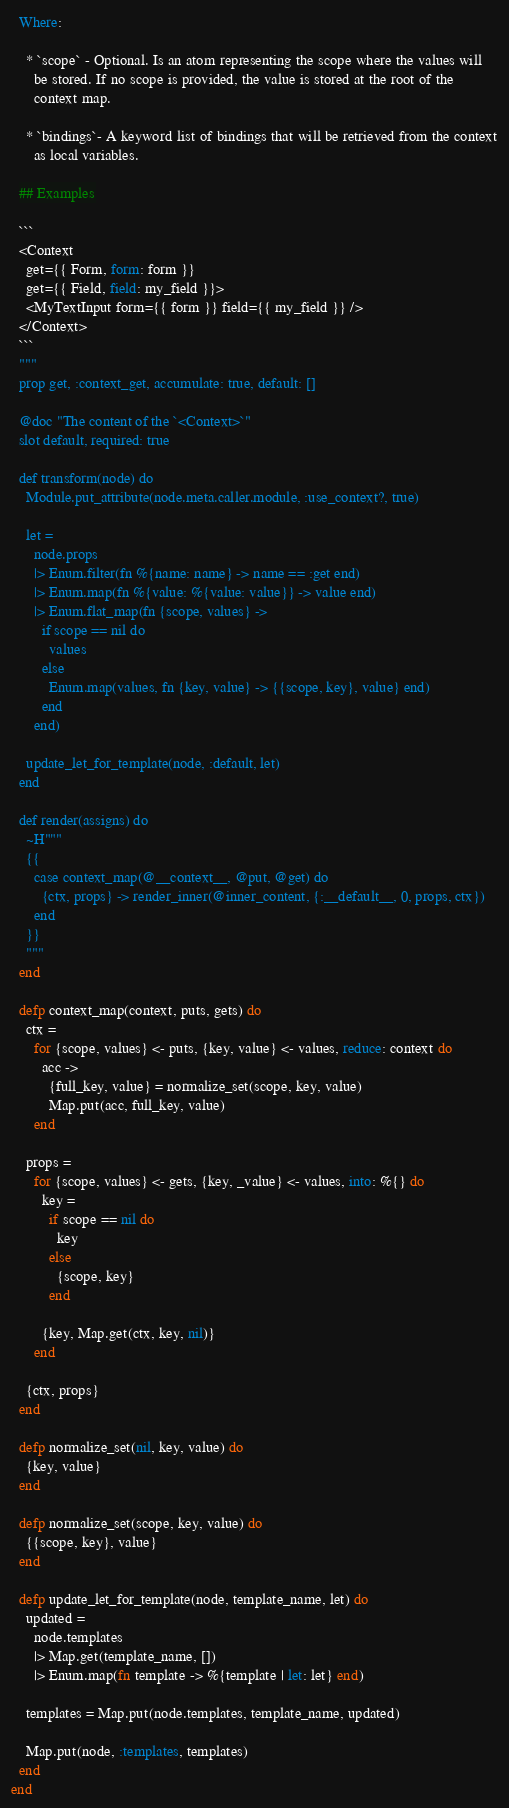<code> <loc_0><loc_0><loc_500><loc_500><_Elixir_>  Where:

    * `scope` - Optional. Is an atom representing the scope where the values will
      be stored. If no scope is provided, the value is stored at the root of the
      context map.

    * `bindings`- A keyword list of bindings that will be retrieved from the context
      as local variables.

  ## Examples

  ```
  <Context
    get={{ Form, form: form }}
    get={{ Field, field: my_field }}>
    <MyTextInput form={{ form }} field={{ my_field }} />
  </Context>
  ```
  """
  prop get, :context_get, accumulate: true, default: []

  @doc "The content of the `<Context>`"
  slot default, required: true

  def transform(node) do
    Module.put_attribute(node.meta.caller.module, :use_context?, true)

    let =
      node.props
      |> Enum.filter(fn %{name: name} -> name == :get end)
      |> Enum.map(fn %{value: %{value: value}} -> value end)
      |> Enum.flat_map(fn {scope, values} ->
        if scope == nil do
          values
        else
          Enum.map(values, fn {key, value} -> {{scope, key}, value} end)
        end
      end)

    update_let_for_template(node, :default, let)
  end

  def render(assigns) do
    ~H"""
    {{
      case context_map(@__context__, @put, @get) do
        {ctx, props} -> render_inner(@inner_content, {:__default__, 0, props, ctx})
      end
    }}
    """
  end

  defp context_map(context, puts, gets) do
    ctx =
      for {scope, values} <- puts, {key, value} <- values, reduce: context do
        acc ->
          {full_key, value} = normalize_set(scope, key, value)
          Map.put(acc, full_key, value)
      end

    props =
      for {scope, values} <- gets, {key, _value} <- values, into: %{} do
        key =
          if scope == nil do
            key
          else
            {scope, key}
          end

        {key, Map.get(ctx, key, nil)}
      end

    {ctx, props}
  end

  defp normalize_set(nil, key, value) do
    {key, value}
  end

  defp normalize_set(scope, key, value) do
    {{scope, key}, value}
  end

  defp update_let_for_template(node, template_name, let) do
    updated =
      node.templates
      |> Map.get(template_name, [])
      |> Enum.map(fn template -> %{template | let: let} end)

    templates = Map.put(node.templates, template_name, updated)

    Map.put(node, :templates, templates)
  end
end
</code> 